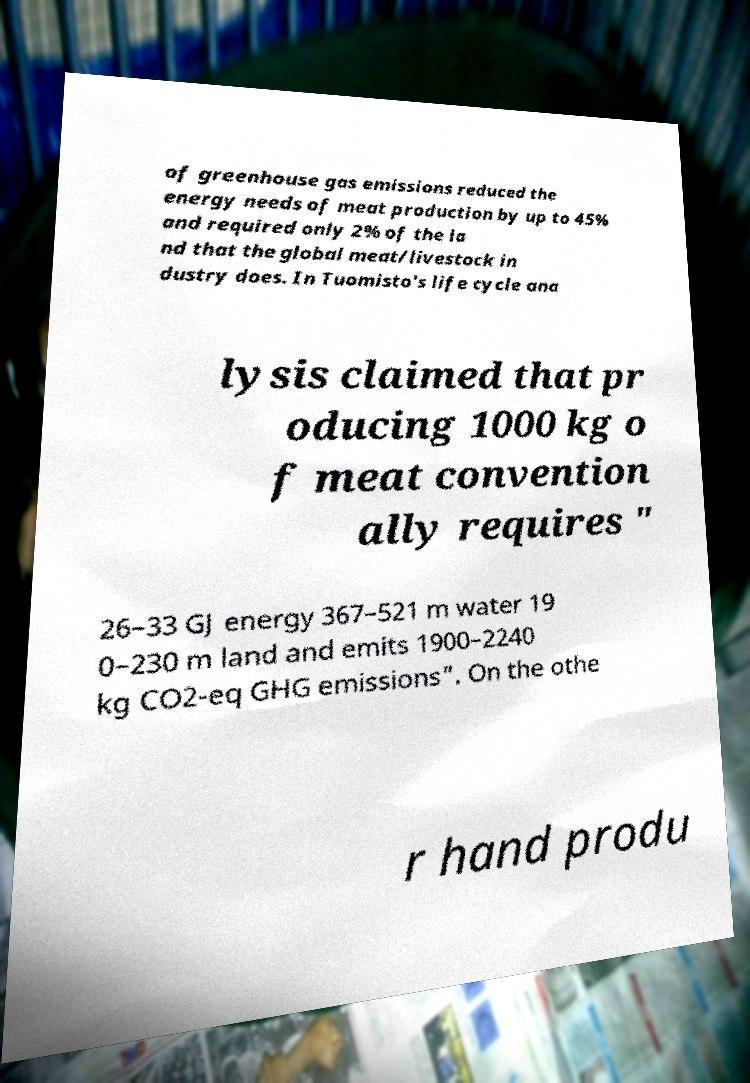Please read and relay the text visible in this image. What does it say? of greenhouse gas emissions reduced the energy needs of meat production by up to 45% and required only 2% of the la nd that the global meat/livestock in dustry does. In Tuomisto's life cycle ana lysis claimed that pr oducing 1000 kg o f meat convention ally requires " 26–33 GJ energy 367–521 m water 19 0–230 m land and emits 1900–2240 kg CO2-eq GHG emissions". On the othe r hand produ 